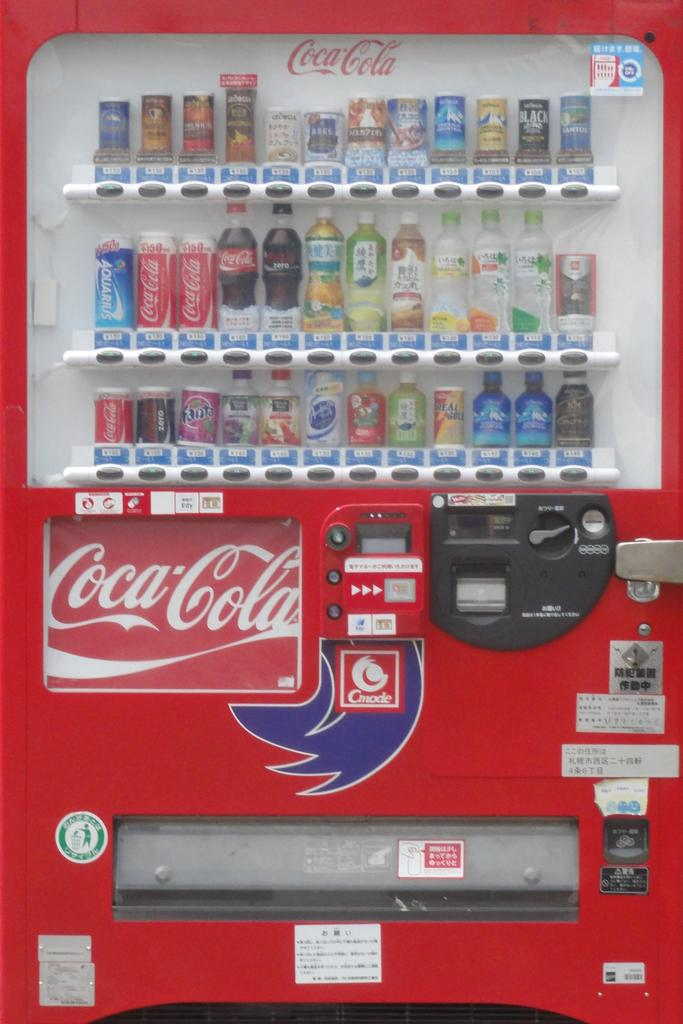<image>
Render a clear and concise summary of the photo. The Coca cola vending machine has a large variety of sodas and juices to choose from. 